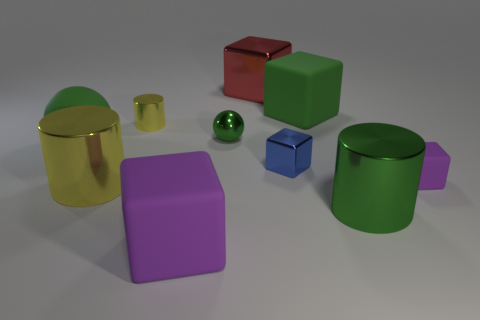Can you tell me the colors of the objects? Certainly! In the image, there are objects in gold, green, red, purple, blue, and yellow colors. Are they all solid colors or do any have patterns? All objects in the image have solid colors with no visible patterns or designs on them. 